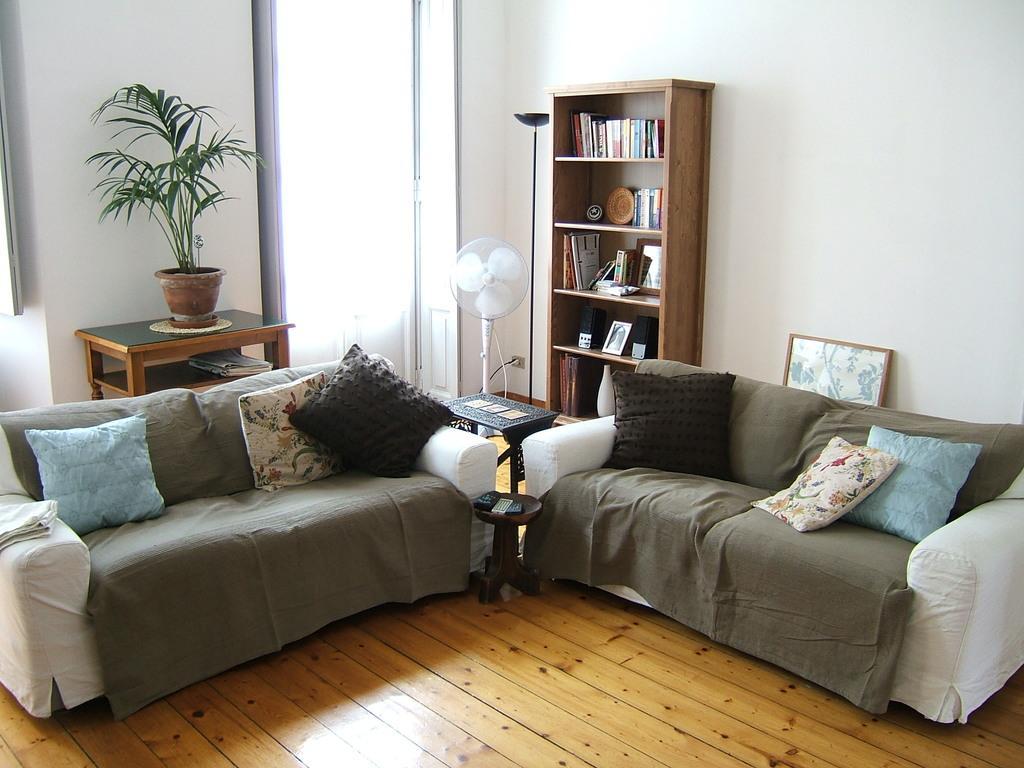Can you describe this image briefly? In this picture in the center there are sofas and on the sofas there are pillows, there is an empty table which is black in colour and in front of the sofa there is a stool and on the stool there are objects which are white and black in colour. In the background there is a fan and there is a shelf, in the shelf there are books and there are frames, on the right side behind the sofa there is a frame. In the background there is a table and on the table there is a plant in the pot and there is a wall and there is a stand which is black in colour. 